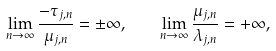<formula> <loc_0><loc_0><loc_500><loc_500>\lim _ { n \to \infty } \frac { - \tau _ { j , n } } { \mu _ { j , n } } = \pm \infty , \quad \lim _ { n \to \infty } \frac { \mu _ { j , n } } { \lambda _ { j , n } } = + \infty ,</formula> 